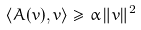<formula> <loc_0><loc_0><loc_500><loc_500>\langle A ( v ) , v \rangle \geq \alpha \, \| v \| ^ { 2 }</formula> 